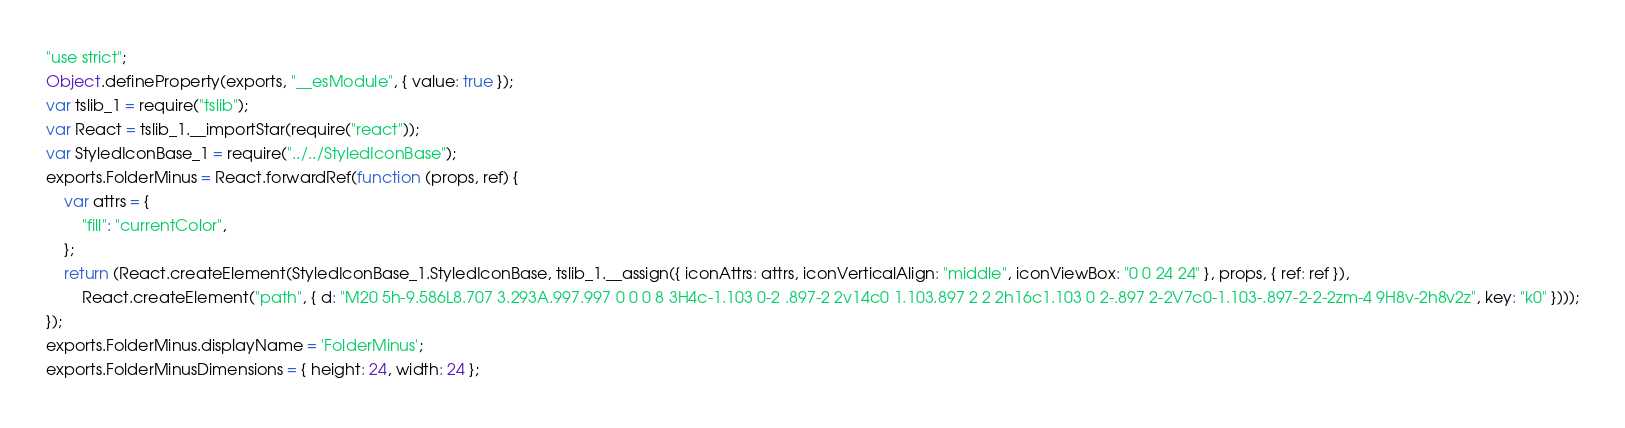Convert code to text. <code><loc_0><loc_0><loc_500><loc_500><_JavaScript_>"use strict";
Object.defineProperty(exports, "__esModule", { value: true });
var tslib_1 = require("tslib");
var React = tslib_1.__importStar(require("react"));
var StyledIconBase_1 = require("../../StyledIconBase");
exports.FolderMinus = React.forwardRef(function (props, ref) {
    var attrs = {
        "fill": "currentColor",
    };
    return (React.createElement(StyledIconBase_1.StyledIconBase, tslib_1.__assign({ iconAttrs: attrs, iconVerticalAlign: "middle", iconViewBox: "0 0 24 24" }, props, { ref: ref }),
        React.createElement("path", { d: "M20 5h-9.586L8.707 3.293A.997.997 0 0 0 8 3H4c-1.103 0-2 .897-2 2v14c0 1.103.897 2 2 2h16c1.103 0 2-.897 2-2V7c0-1.103-.897-2-2-2zm-4 9H8v-2h8v2z", key: "k0" })));
});
exports.FolderMinus.displayName = 'FolderMinus';
exports.FolderMinusDimensions = { height: 24, width: 24 };
</code> 